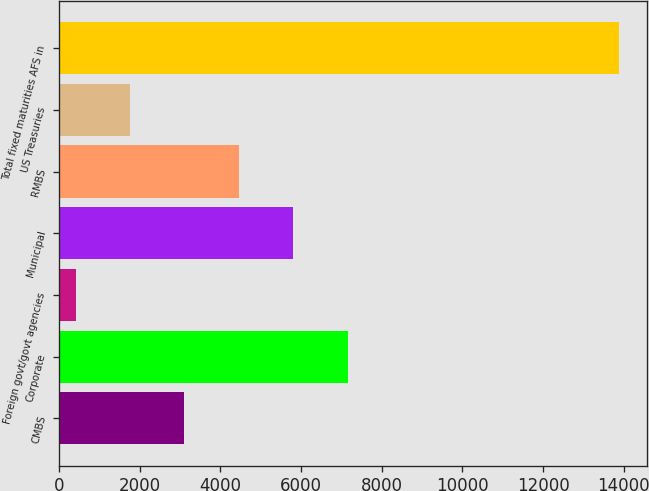<chart> <loc_0><loc_0><loc_500><loc_500><bar_chart><fcel>CMBS<fcel>Corporate<fcel>Foreign govt/govt agencies<fcel>Municipal<fcel>RMBS<fcel>US Treasuries<fcel>Total fixed maturities AFS in<nl><fcel>3102.6<fcel>7174<fcel>407<fcel>5798.2<fcel>4450.4<fcel>1754.8<fcel>13885<nl></chart> 